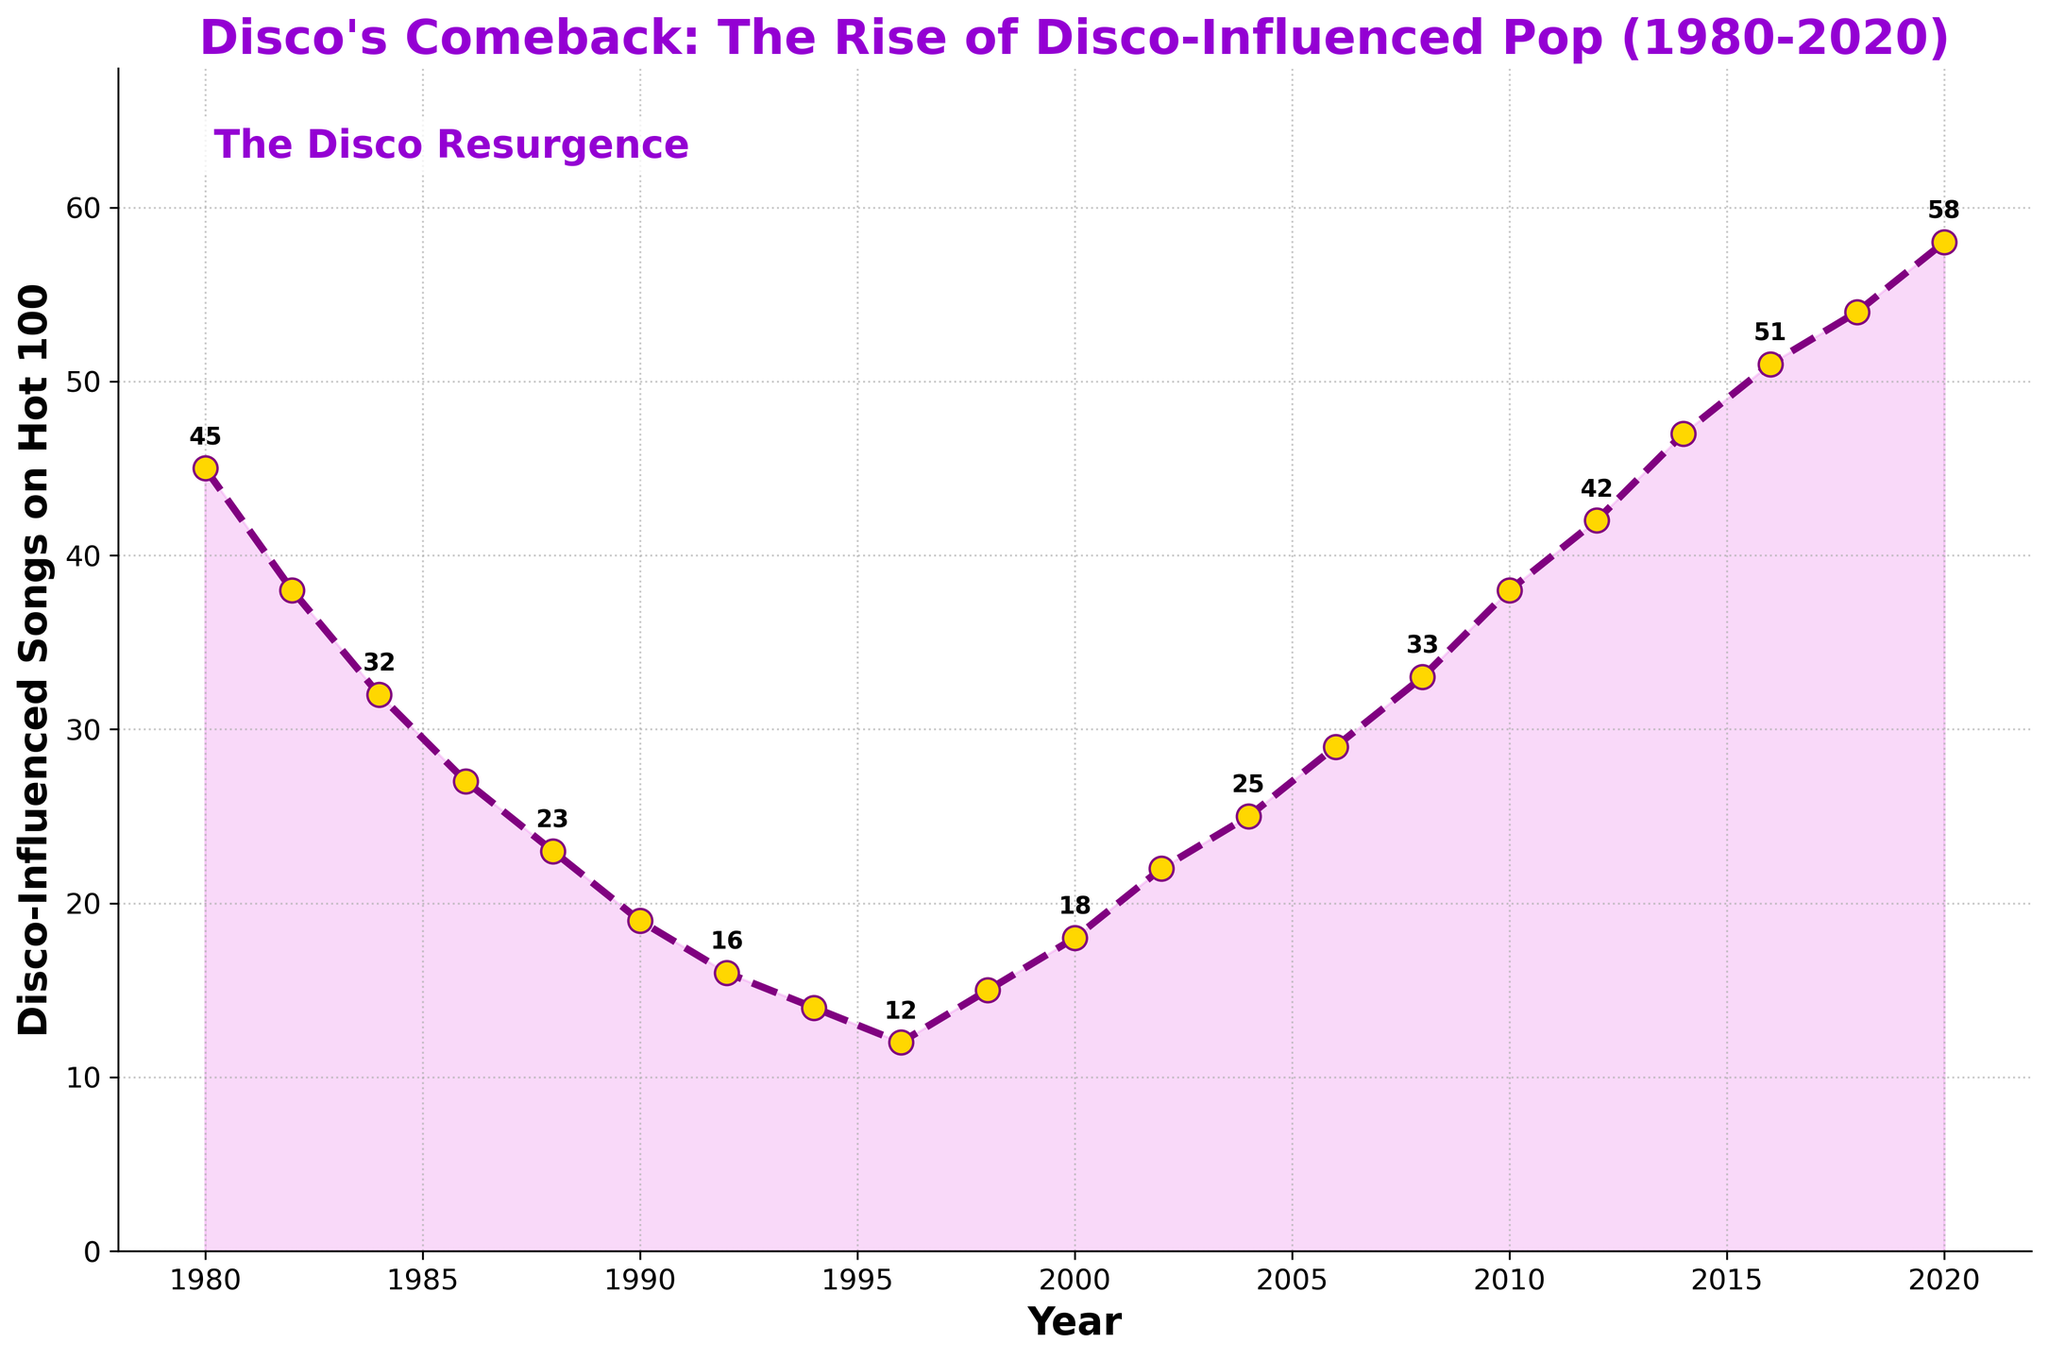What's the highest number of disco-influenced songs on the Billboard Hot 100? To find the highest number, look for the peak point on the line plot. The highest peak corresponds to the year 2020 where the value reaches 58.
Answer: 58 In which year did the trend of disco-influenced songs begin an increasing trend after the lowest point in the 1990s? Identify the lowest point in the 1990s, which occurs at 1996 with 12 songs. Look for the subsequent year when the trend starts to consistently increase. The trend begins an upward movement from the year 1998.
Answer: 1998 How many disco-influenced songs were on the Billboard Hot 100 in 2004 compared to 1986? Look at the specific data points for both years: 2004 shows 25 songs and 1986 shows 27 songs. Subtract to find the difference: 27 - 25 = 2. Thus, there were 2 fewer songs in 2004 than in 1986.
Answer: 2 fewer What was the average number of disco-influenced songs on the Billboard Hot 100 during the 1980s? List the values for the 1980s: 45 (1980), 38 (1982), 32 (1984), 27 (1986), and 23 (1988). Find the sum: 45 + 38 + 32 + 27 + 23 = 165. Divide by the number of years: 165 / 5 = 33.
Answer: 33 How many disco-influenced songs were added to the Billboard Hot 100 from 2000 to 2020? Get the song counts for 2000 (18) and for 2020 (58). Subtract the 2000 value from the 2020 value: 58 - 18 = 40, thus 40 more songs were added.
Answer: 40 Between 1992 and 1996, was there an increasing or decreasing trend in the number of disco-influenced songs? Look at the values for 1992 (16), 1994 (14), and 1996 (12). We observe a continual decline. Thus, the trend was decreasing.
Answer: Decreasing Identify the years when the number of disco-influenced songs on the Billboard Hot 100 was exactly 25? Check the values provided for each year. The year 2004 has exactly 25 songs.
Answer: 2004 How many years have more than 50 disco-influenced songs on the Billboard Hot 100? Identify the years where the song count is above 50: 2016 (51), 2018 (54), and 2020 (58). Count these years: 3 years.
Answer: 3 Compare the number of disco-influenced songs in 1980 and 2014, and explain the trend. Check the values: 45 for 1980 and 47 for 2014. Compare the two numbers: in 2014, there are 2 more songs than in 1980. This indicates a resurgence and growth in disco-influenced songs.
Answer: 2 more in 2014 Which decades showed a decline in disco-influenced songs and which showed an increase? Analyze the plot: 
- Decline in the 1980s (45 in 1980 to 19 in 1990), 
- Slight decline in the 1990s (19 in 1990 to 15 in 1998),
- Increase post-2000 (18 in 2000 to 58 in 2020). 
Therefore, the 1980s and 1990s showed declines, while the 2000s and 2010s showed increases.
Answer: 1980s and 1990s (decline), 2000s and 2010s (increase) 